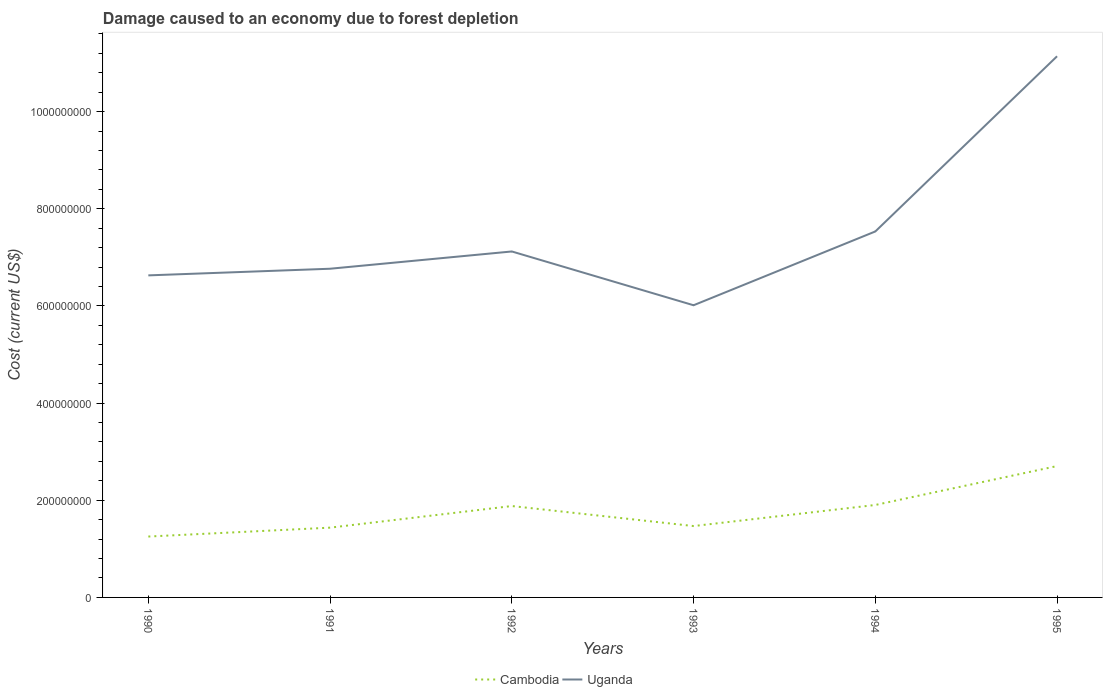How many different coloured lines are there?
Make the answer very short. 2. Across all years, what is the maximum cost of damage caused due to forest depletion in Uganda?
Your response must be concise. 6.01e+08. In which year was the cost of damage caused due to forest depletion in Uganda maximum?
Make the answer very short. 1993. What is the total cost of damage caused due to forest depletion in Uganda in the graph?
Provide a short and direct response. 7.52e+07. What is the difference between the highest and the second highest cost of damage caused due to forest depletion in Uganda?
Your answer should be compact. 5.13e+08. What is the difference between the highest and the lowest cost of damage caused due to forest depletion in Uganda?
Offer a terse response. 1. Are the values on the major ticks of Y-axis written in scientific E-notation?
Your answer should be compact. No. Does the graph contain grids?
Your response must be concise. No. Where does the legend appear in the graph?
Your response must be concise. Bottom center. What is the title of the graph?
Ensure brevity in your answer.  Damage caused to an economy due to forest depletion. Does "Italy" appear as one of the legend labels in the graph?
Ensure brevity in your answer.  No. What is the label or title of the X-axis?
Provide a short and direct response. Years. What is the label or title of the Y-axis?
Provide a succinct answer. Cost (current US$). What is the Cost (current US$) of Cambodia in 1990?
Offer a terse response. 1.25e+08. What is the Cost (current US$) in Uganda in 1990?
Give a very brief answer. 6.63e+08. What is the Cost (current US$) in Cambodia in 1991?
Keep it short and to the point. 1.44e+08. What is the Cost (current US$) of Uganda in 1991?
Offer a terse response. 6.77e+08. What is the Cost (current US$) in Cambodia in 1992?
Offer a very short reply. 1.88e+08. What is the Cost (current US$) in Uganda in 1992?
Make the answer very short. 7.12e+08. What is the Cost (current US$) in Cambodia in 1993?
Your answer should be very brief. 1.47e+08. What is the Cost (current US$) of Uganda in 1993?
Provide a succinct answer. 6.01e+08. What is the Cost (current US$) in Cambodia in 1994?
Your answer should be very brief. 1.90e+08. What is the Cost (current US$) of Uganda in 1994?
Offer a very short reply. 7.53e+08. What is the Cost (current US$) in Cambodia in 1995?
Keep it short and to the point. 2.70e+08. What is the Cost (current US$) in Uganda in 1995?
Provide a short and direct response. 1.11e+09. Across all years, what is the maximum Cost (current US$) of Cambodia?
Your answer should be very brief. 2.70e+08. Across all years, what is the maximum Cost (current US$) in Uganda?
Your answer should be very brief. 1.11e+09. Across all years, what is the minimum Cost (current US$) of Cambodia?
Offer a very short reply. 1.25e+08. Across all years, what is the minimum Cost (current US$) of Uganda?
Ensure brevity in your answer.  6.01e+08. What is the total Cost (current US$) in Cambodia in the graph?
Keep it short and to the point. 1.06e+09. What is the total Cost (current US$) of Uganda in the graph?
Your answer should be very brief. 4.52e+09. What is the difference between the Cost (current US$) of Cambodia in 1990 and that in 1991?
Give a very brief answer. -1.83e+07. What is the difference between the Cost (current US$) of Uganda in 1990 and that in 1991?
Keep it short and to the point. -1.37e+07. What is the difference between the Cost (current US$) of Cambodia in 1990 and that in 1992?
Offer a terse response. -6.28e+07. What is the difference between the Cost (current US$) in Uganda in 1990 and that in 1992?
Make the answer very short. -4.92e+07. What is the difference between the Cost (current US$) in Cambodia in 1990 and that in 1993?
Provide a succinct answer. -2.16e+07. What is the difference between the Cost (current US$) of Uganda in 1990 and that in 1993?
Give a very brief answer. 6.15e+07. What is the difference between the Cost (current US$) of Cambodia in 1990 and that in 1994?
Keep it short and to the point. -6.50e+07. What is the difference between the Cost (current US$) of Uganda in 1990 and that in 1994?
Your answer should be compact. -9.04e+07. What is the difference between the Cost (current US$) in Cambodia in 1990 and that in 1995?
Make the answer very short. -1.45e+08. What is the difference between the Cost (current US$) of Uganda in 1990 and that in 1995?
Provide a short and direct response. -4.51e+08. What is the difference between the Cost (current US$) of Cambodia in 1991 and that in 1992?
Make the answer very short. -4.45e+07. What is the difference between the Cost (current US$) in Uganda in 1991 and that in 1992?
Offer a very short reply. -3.55e+07. What is the difference between the Cost (current US$) of Cambodia in 1991 and that in 1993?
Offer a very short reply. -3.28e+06. What is the difference between the Cost (current US$) in Uganda in 1991 and that in 1993?
Provide a short and direct response. 7.52e+07. What is the difference between the Cost (current US$) of Cambodia in 1991 and that in 1994?
Provide a succinct answer. -4.67e+07. What is the difference between the Cost (current US$) in Uganda in 1991 and that in 1994?
Offer a very short reply. -7.67e+07. What is the difference between the Cost (current US$) of Cambodia in 1991 and that in 1995?
Your answer should be very brief. -1.27e+08. What is the difference between the Cost (current US$) of Uganda in 1991 and that in 1995?
Provide a succinct answer. -4.37e+08. What is the difference between the Cost (current US$) of Cambodia in 1992 and that in 1993?
Your answer should be very brief. 4.12e+07. What is the difference between the Cost (current US$) of Uganda in 1992 and that in 1993?
Your response must be concise. 1.11e+08. What is the difference between the Cost (current US$) in Cambodia in 1992 and that in 1994?
Provide a short and direct response. -2.17e+06. What is the difference between the Cost (current US$) in Uganda in 1992 and that in 1994?
Keep it short and to the point. -4.12e+07. What is the difference between the Cost (current US$) in Cambodia in 1992 and that in 1995?
Offer a terse response. -8.23e+07. What is the difference between the Cost (current US$) in Uganda in 1992 and that in 1995?
Provide a short and direct response. -4.02e+08. What is the difference between the Cost (current US$) of Cambodia in 1993 and that in 1994?
Offer a very short reply. -4.34e+07. What is the difference between the Cost (current US$) in Uganda in 1993 and that in 1994?
Keep it short and to the point. -1.52e+08. What is the difference between the Cost (current US$) in Cambodia in 1993 and that in 1995?
Your response must be concise. -1.23e+08. What is the difference between the Cost (current US$) in Uganda in 1993 and that in 1995?
Offer a terse response. -5.13e+08. What is the difference between the Cost (current US$) in Cambodia in 1994 and that in 1995?
Offer a very short reply. -8.01e+07. What is the difference between the Cost (current US$) of Uganda in 1994 and that in 1995?
Ensure brevity in your answer.  -3.61e+08. What is the difference between the Cost (current US$) of Cambodia in 1990 and the Cost (current US$) of Uganda in 1991?
Your answer should be very brief. -5.51e+08. What is the difference between the Cost (current US$) in Cambodia in 1990 and the Cost (current US$) in Uganda in 1992?
Offer a terse response. -5.87e+08. What is the difference between the Cost (current US$) in Cambodia in 1990 and the Cost (current US$) in Uganda in 1993?
Your answer should be compact. -4.76e+08. What is the difference between the Cost (current US$) of Cambodia in 1990 and the Cost (current US$) of Uganda in 1994?
Your answer should be very brief. -6.28e+08. What is the difference between the Cost (current US$) of Cambodia in 1990 and the Cost (current US$) of Uganda in 1995?
Ensure brevity in your answer.  -9.89e+08. What is the difference between the Cost (current US$) of Cambodia in 1991 and the Cost (current US$) of Uganda in 1992?
Provide a short and direct response. -5.69e+08. What is the difference between the Cost (current US$) in Cambodia in 1991 and the Cost (current US$) in Uganda in 1993?
Give a very brief answer. -4.58e+08. What is the difference between the Cost (current US$) in Cambodia in 1991 and the Cost (current US$) in Uganda in 1994?
Your answer should be compact. -6.10e+08. What is the difference between the Cost (current US$) in Cambodia in 1991 and the Cost (current US$) in Uganda in 1995?
Make the answer very short. -9.70e+08. What is the difference between the Cost (current US$) in Cambodia in 1992 and the Cost (current US$) in Uganda in 1993?
Your answer should be very brief. -4.13e+08. What is the difference between the Cost (current US$) of Cambodia in 1992 and the Cost (current US$) of Uganda in 1994?
Make the answer very short. -5.65e+08. What is the difference between the Cost (current US$) of Cambodia in 1992 and the Cost (current US$) of Uganda in 1995?
Your response must be concise. -9.26e+08. What is the difference between the Cost (current US$) in Cambodia in 1993 and the Cost (current US$) in Uganda in 1994?
Provide a short and direct response. -6.06e+08. What is the difference between the Cost (current US$) of Cambodia in 1993 and the Cost (current US$) of Uganda in 1995?
Provide a succinct answer. -9.67e+08. What is the difference between the Cost (current US$) in Cambodia in 1994 and the Cost (current US$) in Uganda in 1995?
Provide a succinct answer. -9.24e+08. What is the average Cost (current US$) of Cambodia per year?
Keep it short and to the point. 1.77e+08. What is the average Cost (current US$) of Uganda per year?
Your answer should be compact. 7.53e+08. In the year 1990, what is the difference between the Cost (current US$) in Cambodia and Cost (current US$) in Uganda?
Your answer should be very brief. -5.38e+08. In the year 1991, what is the difference between the Cost (current US$) in Cambodia and Cost (current US$) in Uganda?
Give a very brief answer. -5.33e+08. In the year 1992, what is the difference between the Cost (current US$) in Cambodia and Cost (current US$) in Uganda?
Give a very brief answer. -5.24e+08. In the year 1993, what is the difference between the Cost (current US$) of Cambodia and Cost (current US$) of Uganda?
Make the answer very short. -4.55e+08. In the year 1994, what is the difference between the Cost (current US$) in Cambodia and Cost (current US$) in Uganda?
Your answer should be compact. -5.63e+08. In the year 1995, what is the difference between the Cost (current US$) in Cambodia and Cost (current US$) in Uganda?
Make the answer very short. -8.44e+08. What is the ratio of the Cost (current US$) of Cambodia in 1990 to that in 1991?
Offer a very short reply. 0.87. What is the ratio of the Cost (current US$) of Uganda in 1990 to that in 1991?
Ensure brevity in your answer.  0.98. What is the ratio of the Cost (current US$) in Cambodia in 1990 to that in 1992?
Offer a terse response. 0.67. What is the ratio of the Cost (current US$) of Uganda in 1990 to that in 1992?
Offer a very short reply. 0.93. What is the ratio of the Cost (current US$) in Cambodia in 1990 to that in 1993?
Your answer should be very brief. 0.85. What is the ratio of the Cost (current US$) of Uganda in 1990 to that in 1993?
Keep it short and to the point. 1.1. What is the ratio of the Cost (current US$) of Cambodia in 1990 to that in 1994?
Provide a succinct answer. 0.66. What is the ratio of the Cost (current US$) in Cambodia in 1990 to that in 1995?
Ensure brevity in your answer.  0.46. What is the ratio of the Cost (current US$) in Uganda in 1990 to that in 1995?
Your response must be concise. 0.6. What is the ratio of the Cost (current US$) in Cambodia in 1991 to that in 1992?
Ensure brevity in your answer.  0.76. What is the ratio of the Cost (current US$) in Uganda in 1991 to that in 1992?
Offer a terse response. 0.95. What is the ratio of the Cost (current US$) in Cambodia in 1991 to that in 1993?
Ensure brevity in your answer.  0.98. What is the ratio of the Cost (current US$) in Cambodia in 1991 to that in 1994?
Offer a terse response. 0.75. What is the ratio of the Cost (current US$) in Uganda in 1991 to that in 1994?
Your answer should be compact. 0.9. What is the ratio of the Cost (current US$) of Cambodia in 1991 to that in 1995?
Offer a very short reply. 0.53. What is the ratio of the Cost (current US$) of Uganda in 1991 to that in 1995?
Provide a short and direct response. 0.61. What is the ratio of the Cost (current US$) of Cambodia in 1992 to that in 1993?
Give a very brief answer. 1.28. What is the ratio of the Cost (current US$) of Uganda in 1992 to that in 1993?
Offer a terse response. 1.18. What is the ratio of the Cost (current US$) of Cambodia in 1992 to that in 1994?
Provide a succinct answer. 0.99. What is the ratio of the Cost (current US$) of Uganda in 1992 to that in 1994?
Offer a very short reply. 0.95. What is the ratio of the Cost (current US$) of Cambodia in 1992 to that in 1995?
Ensure brevity in your answer.  0.7. What is the ratio of the Cost (current US$) in Uganda in 1992 to that in 1995?
Your response must be concise. 0.64. What is the ratio of the Cost (current US$) of Cambodia in 1993 to that in 1994?
Keep it short and to the point. 0.77. What is the ratio of the Cost (current US$) of Uganda in 1993 to that in 1994?
Keep it short and to the point. 0.8. What is the ratio of the Cost (current US$) in Cambodia in 1993 to that in 1995?
Your answer should be compact. 0.54. What is the ratio of the Cost (current US$) of Uganda in 1993 to that in 1995?
Provide a succinct answer. 0.54. What is the ratio of the Cost (current US$) in Cambodia in 1994 to that in 1995?
Ensure brevity in your answer.  0.7. What is the ratio of the Cost (current US$) of Uganda in 1994 to that in 1995?
Your answer should be very brief. 0.68. What is the difference between the highest and the second highest Cost (current US$) in Cambodia?
Provide a short and direct response. 8.01e+07. What is the difference between the highest and the second highest Cost (current US$) in Uganda?
Offer a terse response. 3.61e+08. What is the difference between the highest and the lowest Cost (current US$) of Cambodia?
Offer a very short reply. 1.45e+08. What is the difference between the highest and the lowest Cost (current US$) of Uganda?
Keep it short and to the point. 5.13e+08. 